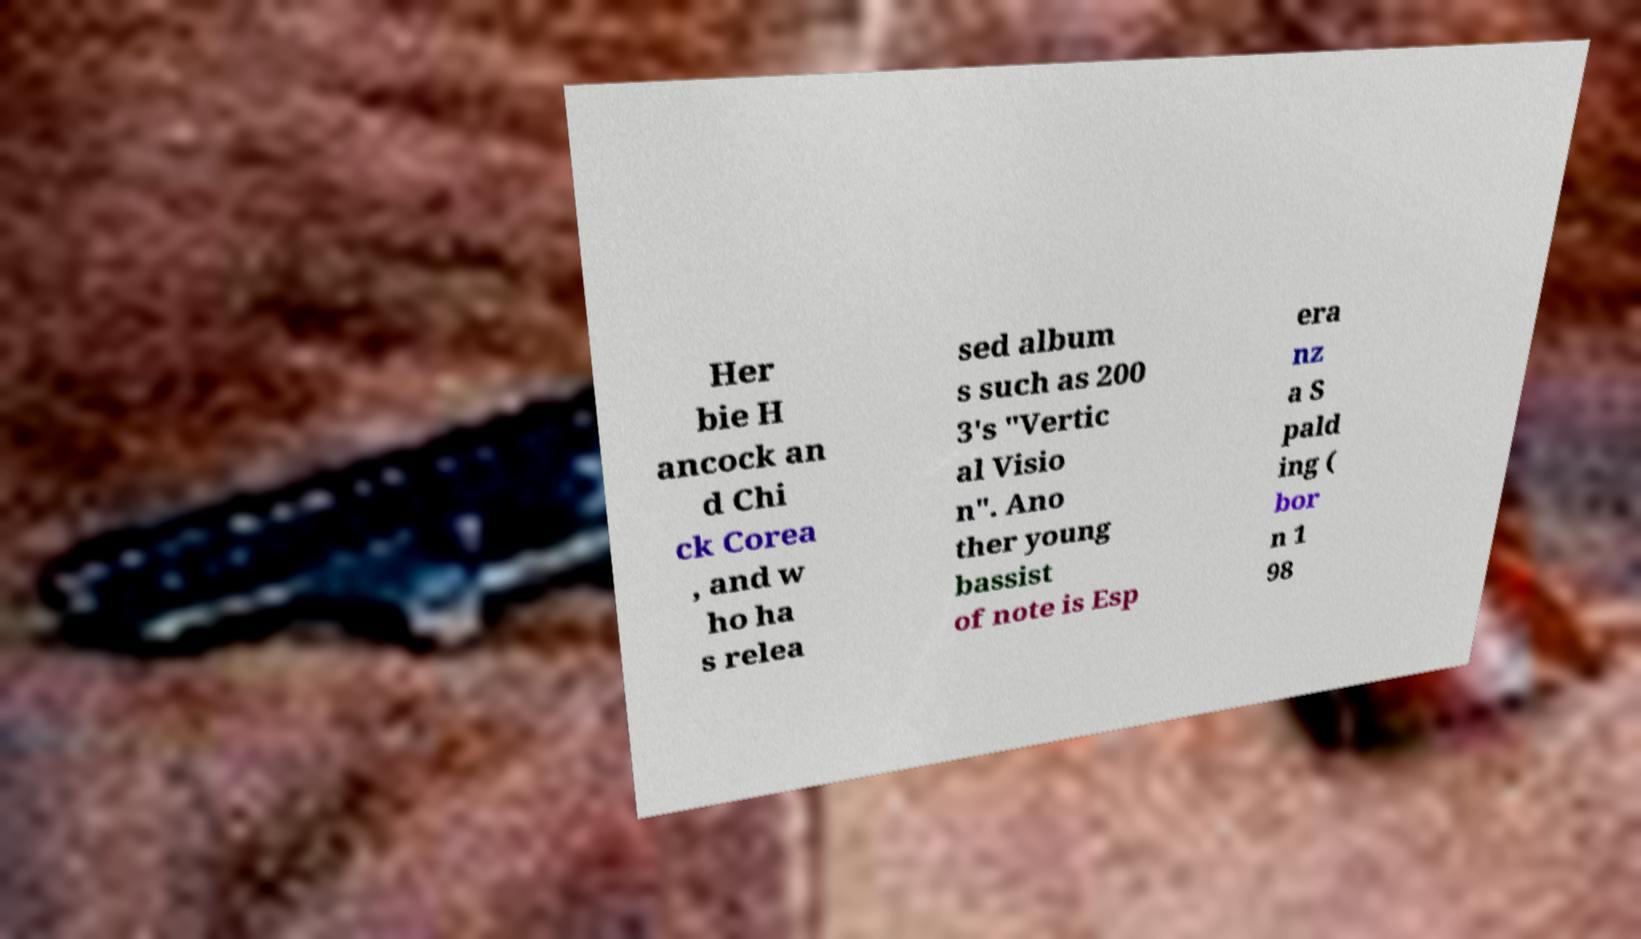Could you assist in decoding the text presented in this image and type it out clearly? Her bie H ancock an d Chi ck Corea , and w ho ha s relea sed album s such as 200 3's "Vertic al Visio n". Ano ther young bassist of note is Esp era nz a S pald ing ( bor n 1 98 